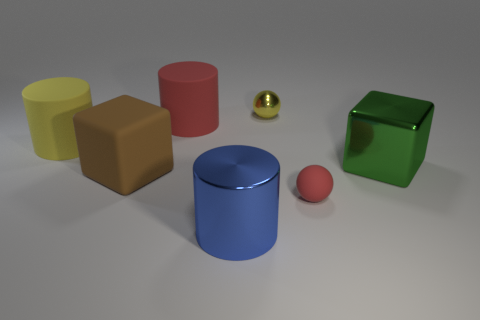Are there fewer brown objects that are to the right of the red matte cylinder than big purple rubber cylinders?
Provide a succinct answer. No. Do the big brown thing and the tiny rubber object have the same shape?
Your response must be concise. No. What is the size of the blue cylinder that is the same material as the yellow sphere?
Your answer should be compact. Large. Is the number of yellow things less than the number of red rubber cylinders?
Provide a short and direct response. No. How many large objects are either cylinders or red rubber cylinders?
Provide a succinct answer. 3. What number of objects are both to the right of the big brown cube and to the left of the big metallic block?
Make the answer very short. 4. Is the number of yellow cylinders greater than the number of big things?
Offer a very short reply. No. What number of other things are there of the same shape as the tiny red thing?
Your answer should be very brief. 1. What material is the large cylinder that is in front of the big red matte thing and behind the matte sphere?
Provide a succinct answer. Rubber. The blue shiny thing has what size?
Your response must be concise. Large. 